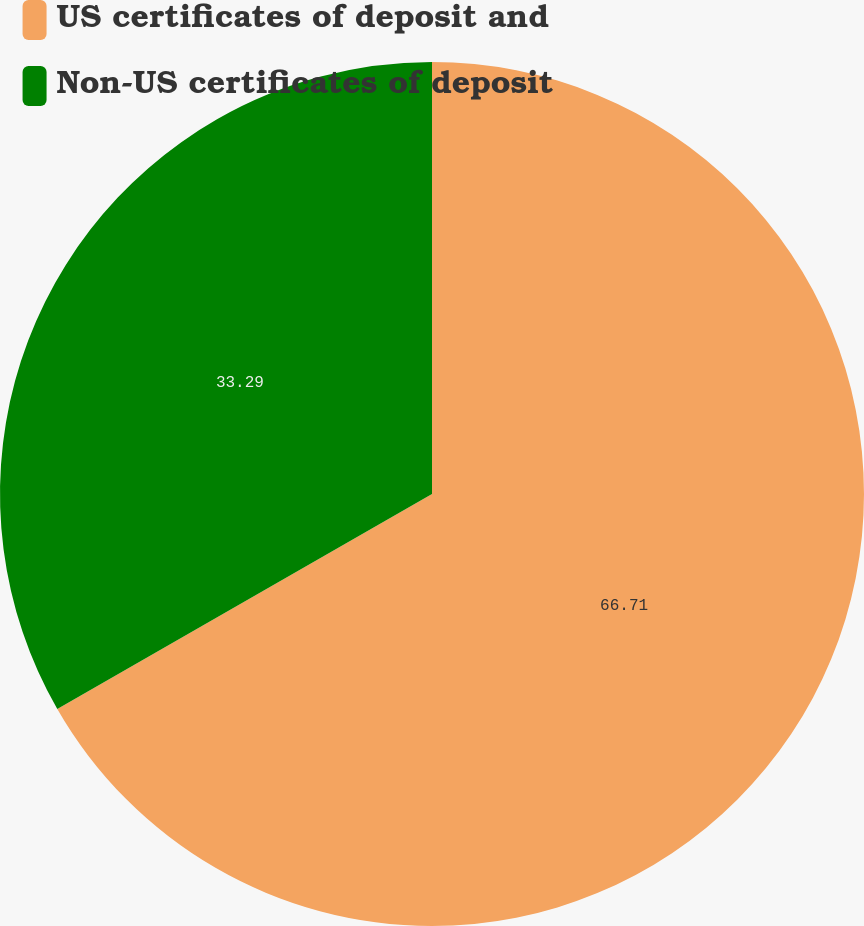<chart> <loc_0><loc_0><loc_500><loc_500><pie_chart><fcel>US certificates of deposit and<fcel>Non-US certificates of deposit<nl><fcel>66.71%<fcel>33.29%<nl></chart> 